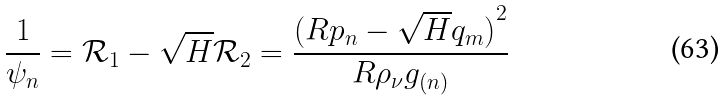<formula> <loc_0><loc_0><loc_500><loc_500>\frac { 1 } { \psi _ { n } } = \mathcal { R } _ { 1 } - \sqrt { H } \mathcal { R } _ { 2 } = \frac { { ( R p _ { n } - \sqrt { H } q _ { m } ) } ^ { 2 } } { R \rho _ { \nu } g _ { ( n ) } }</formula> 